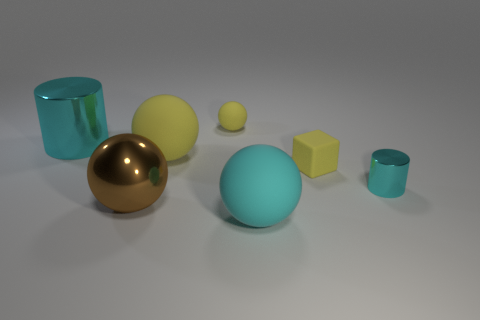There is a matte sphere that is the same size as the cube; what color is it?
Make the answer very short. Yellow. There is a metallic object right of the tiny yellow matte ball; does it have the same color as the big metallic cylinder?
Offer a very short reply. Yes. Are there any cyan cylinders made of the same material as the tiny ball?
Your response must be concise. No. There is a big shiny thing that is the same color as the small metal thing; what shape is it?
Keep it short and to the point. Cylinder. Is the number of brown spheres that are on the right side of the small yellow matte sphere less than the number of small red metal cubes?
Ensure brevity in your answer.  No. There is a cyan thing that is in front of the brown thing; does it have the same size as the small cyan shiny object?
Make the answer very short. No. How many other things have the same shape as the large yellow object?
Make the answer very short. 3. There is another cylinder that is made of the same material as the big cylinder; what size is it?
Make the answer very short. Small. Are there the same number of big matte balls in front of the big cyan rubber object and tiny blocks?
Offer a terse response. No. Does the block have the same color as the tiny matte sphere?
Offer a very short reply. Yes. 